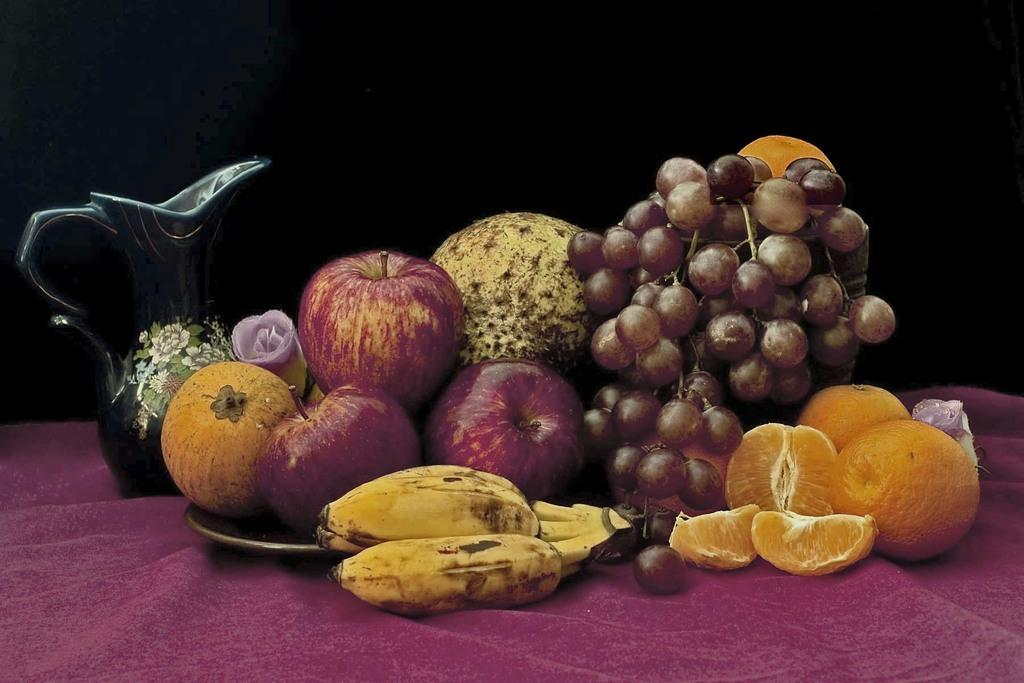What type of food items are present in the image? There are fruits in the image. What is used to serve the fruits in the image? There is a plate in the image. What other object can be seen in the image besides the plate? There is a mug in the image. On what surface are the plate and mug placed? The objects are placed on a cloth. What type of badge can be seen on the fruits in the image? There is no badge present on the fruits in the image. How many friends are visible in the image? There are no friends visible in the image; it features fruits, a plate, a mug, and a cloth. 